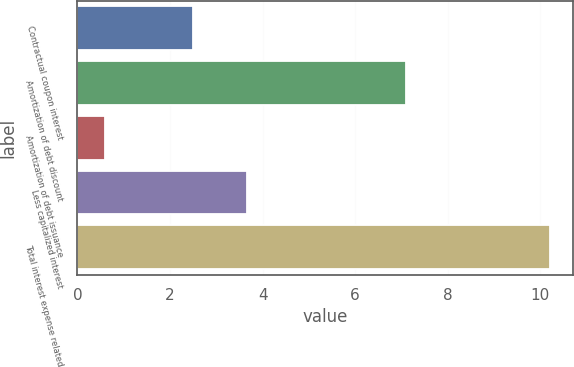<chart> <loc_0><loc_0><loc_500><loc_500><bar_chart><fcel>Contractual coupon interest<fcel>Amortization of debt discount<fcel>Amortization of debt issuance<fcel>Less capitalized interest<fcel>Total interest expense related<nl><fcel>2.5<fcel>7.1<fcel>0.6<fcel>3.67<fcel>10.2<nl></chart> 